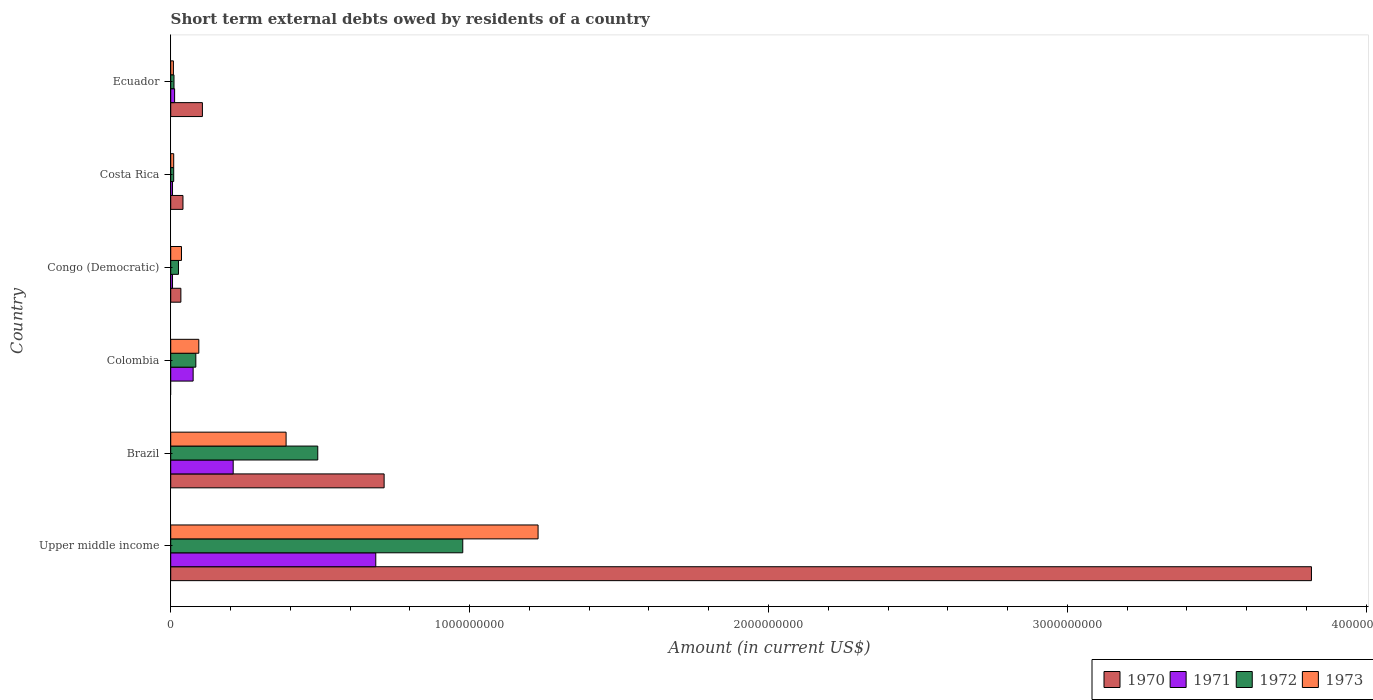How many different coloured bars are there?
Give a very brief answer. 4. How many groups of bars are there?
Ensure brevity in your answer.  6. Are the number of bars per tick equal to the number of legend labels?
Your answer should be compact. No. Are the number of bars on each tick of the Y-axis equal?
Provide a short and direct response. No. How many bars are there on the 4th tick from the top?
Provide a succinct answer. 3. How many bars are there on the 3rd tick from the bottom?
Keep it short and to the point. 3. What is the label of the 6th group of bars from the top?
Your answer should be very brief. Upper middle income. In how many cases, is the number of bars for a given country not equal to the number of legend labels?
Give a very brief answer. 1. What is the amount of short-term external debts owed by residents in 1973 in Upper middle income?
Your response must be concise. 1.23e+09. Across all countries, what is the maximum amount of short-term external debts owed by residents in 1973?
Offer a terse response. 1.23e+09. In which country was the amount of short-term external debts owed by residents in 1971 maximum?
Ensure brevity in your answer.  Upper middle income. What is the total amount of short-term external debts owed by residents in 1971 in the graph?
Provide a succinct answer. 9.95e+08. What is the difference between the amount of short-term external debts owed by residents in 1972 in Colombia and that in Ecuador?
Keep it short and to the point. 7.30e+07. What is the difference between the amount of short-term external debts owed by residents in 1973 in Colombia and the amount of short-term external debts owed by residents in 1972 in Upper middle income?
Ensure brevity in your answer.  -8.83e+08. What is the average amount of short-term external debts owed by residents in 1970 per country?
Make the answer very short. 7.85e+08. What is the difference between the amount of short-term external debts owed by residents in 1972 and amount of short-term external debts owed by residents in 1973 in Colombia?
Provide a succinct answer. -1.00e+07. In how many countries, is the amount of short-term external debts owed by residents in 1970 greater than 800000000 US$?
Make the answer very short. 1. What is the ratio of the amount of short-term external debts owed by residents in 1973 in Brazil to that in Upper middle income?
Provide a succinct answer. 0.31. Is the amount of short-term external debts owed by residents in 1973 in Colombia less than that in Costa Rica?
Provide a succinct answer. No. What is the difference between the highest and the second highest amount of short-term external debts owed by residents in 1972?
Ensure brevity in your answer.  4.85e+08. What is the difference between the highest and the lowest amount of short-term external debts owed by residents in 1971?
Your response must be concise. 6.80e+08. Is the sum of the amount of short-term external debts owed by residents in 1973 in Ecuador and Upper middle income greater than the maximum amount of short-term external debts owed by residents in 1972 across all countries?
Provide a short and direct response. Yes. Are all the bars in the graph horizontal?
Your answer should be compact. Yes. What is the difference between two consecutive major ticks on the X-axis?
Your response must be concise. 1.00e+09. Are the values on the major ticks of X-axis written in scientific E-notation?
Offer a terse response. No. What is the title of the graph?
Keep it short and to the point. Short term external debts owed by residents of a country. What is the label or title of the X-axis?
Your answer should be very brief. Amount (in current US$). What is the Amount (in current US$) in 1970 in Upper middle income?
Your answer should be very brief. 3.82e+09. What is the Amount (in current US$) in 1971 in Upper middle income?
Provide a short and direct response. 6.86e+08. What is the Amount (in current US$) of 1972 in Upper middle income?
Provide a succinct answer. 9.77e+08. What is the Amount (in current US$) in 1973 in Upper middle income?
Provide a succinct answer. 1.23e+09. What is the Amount (in current US$) of 1970 in Brazil?
Make the answer very short. 7.14e+08. What is the Amount (in current US$) in 1971 in Brazil?
Your answer should be very brief. 2.09e+08. What is the Amount (in current US$) in 1972 in Brazil?
Make the answer very short. 4.92e+08. What is the Amount (in current US$) in 1973 in Brazil?
Ensure brevity in your answer.  3.86e+08. What is the Amount (in current US$) in 1971 in Colombia?
Your answer should be very brief. 7.50e+07. What is the Amount (in current US$) in 1972 in Colombia?
Your answer should be very brief. 8.40e+07. What is the Amount (in current US$) of 1973 in Colombia?
Offer a terse response. 9.40e+07. What is the Amount (in current US$) of 1970 in Congo (Democratic)?
Your response must be concise. 3.40e+07. What is the Amount (in current US$) in 1971 in Congo (Democratic)?
Keep it short and to the point. 6.00e+06. What is the Amount (in current US$) in 1972 in Congo (Democratic)?
Make the answer very short. 2.60e+07. What is the Amount (in current US$) of 1973 in Congo (Democratic)?
Your response must be concise. 3.60e+07. What is the Amount (in current US$) in 1970 in Costa Rica?
Ensure brevity in your answer.  4.10e+07. What is the Amount (in current US$) of 1971 in Costa Rica?
Your answer should be compact. 6.00e+06. What is the Amount (in current US$) of 1972 in Costa Rica?
Keep it short and to the point. 1.00e+07. What is the Amount (in current US$) in 1973 in Costa Rica?
Make the answer very short. 1.00e+07. What is the Amount (in current US$) in 1970 in Ecuador?
Keep it short and to the point. 1.06e+08. What is the Amount (in current US$) in 1971 in Ecuador?
Give a very brief answer. 1.30e+07. What is the Amount (in current US$) of 1972 in Ecuador?
Ensure brevity in your answer.  1.10e+07. What is the Amount (in current US$) of 1973 in Ecuador?
Give a very brief answer. 9.00e+06. Across all countries, what is the maximum Amount (in current US$) in 1970?
Offer a terse response. 3.82e+09. Across all countries, what is the maximum Amount (in current US$) in 1971?
Make the answer very short. 6.86e+08. Across all countries, what is the maximum Amount (in current US$) in 1972?
Offer a terse response. 9.77e+08. Across all countries, what is the maximum Amount (in current US$) in 1973?
Your answer should be very brief. 1.23e+09. Across all countries, what is the minimum Amount (in current US$) in 1973?
Offer a terse response. 9.00e+06. What is the total Amount (in current US$) of 1970 in the graph?
Provide a succinct answer. 4.71e+09. What is the total Amount (in current US$) in 1971 in the graph?
Offer a terse response. 9.95e+08. What is the total Amount (in current US$) of 1972 in the graph?
Your response must be concise. 1.60e+09. What is the total Amount (in current US$) of 1973 in the graph?
Ensure brevity in your answer.  1.76e+09. What is the difference between the Amount (in current US$) in 1970 in Upper middle income and that in Brazil?
Give a very brief answer. 3.10e+09. What is the difference between the Amount (in current US$) in 1971 in Upper middle income and that in Brazil?
Provide a succinct answer. 4.77e+08. What is the difference between the Amount (in current US$) of 1972 in Upper middle income and that in Brazil?
Your answer should be compact. 4.85e+08. What is the difference between the Amount (in current US$) in 1973 in Upper middle income and that in Brazil?
Make the answer very short. 8.43e+08. What is the difference between the Amount (in current US$) in 1971 in Upper middle income and that in Colombia?
Offer a terse response. 6.11e+08. What is the difference between the Amount (in current US$) of 1972 in Upper middle income and that in Colombia?
Your response must be concise. 8.93e+08. What is the difference between the Amount (in current US$) in 1973 in Upper middle income and that in Colombia?
Keep it short and to the point. 1.14e+09. What is the difference between the Amount (in current US$) of 1970 in Upper middle income and that in Congo (Democratic)?
Give a very brief answer. 3.78e+09. What is the difference between the Amount (in current US$) of 1971 in Upper middle income and that in Congo (Democratic)?
Provide a short and direct response. 6.80e+08. What is the difference between the Amount (in current US$) of 1972 in Upper middle income and that in Congo (Democratic)?
Ensure brevity in your answer.  9.51e+08. What is the difference between the Amount (in current US$) in 1973 in Upper middle income and that in Congo (Democratic)?
Provide a short and direct response. 1.19e+09. What is the difference between the Amount (in current US$) of 1970 in Upper middle income and that in Costa Rica?
Ensure brevity in your answer.  3.78e+09. What is the difference between the Amount (in current US$) of 1971 in Upper middle income and that in Costa Rica?
Provide a short and direct response. 6.80e+08. What is the difference between the Amount (in current US$) of 1972 in Upper middle income and that in Costa Rica?
Offer a terse response. 9.67e+08. What is the difference between the Amount (in current US$) in 1973 in Upper middle income and that in Costa Rica?
Ensure brevity in your answer.  1.22e+09. What is the difference between the Amount (in current US$) of 1970 in Upper middle income and that in Ecuador?
Keep it short and to the point. 3.71e+09. What is the difference between the Amount (in current US$) in 1971 in Upper middle income and that in Ecuador?
Provide a succinct answer. 6.73e+08. What is the difference between the Amount (in current US$) in 1972 in Upper middle income and that in Ecuador?
Offer a terse response. 9.66e+08. What is the difference between the Amount (in current US$) of 1973 in Upper middle income and that in Ecuador?
Your answer should be compact. 1.22e+09. What is the difference between the Amount (in current US$) of 1971 in Brazil and that in Colombia?
Your answer should be compact. 1.34e+08. What is the difference between the Amount (in current US$) of 1972 in Brazil and that in Colombia?
Offer a very short reply. 4.08e+08. What is the difference between the Amount (in current US$) in 1973 in Brazil and that in Colombia?
Offer a terse response. 2.92e+08. What is the difference between the Amount (in current US$) of 1970 in Brazil and that in Congo (Democratic)?
Provide a succinct answer. 6.80e+08. What is the difference between the Amount (in current US$) in 1971 in Brazil and that in Congo (Democratic)?
Keep it short and to the point. 2.03e+08. What is the difference between the Amount (in current US$) in 1972 in Brazil and that in Congo (Democratic)?
Provide a short and direct response. 4.66e+08. What is the difference between the Amount (in current US$) of 1973 in Brazil and that in Congo (Democratic)?
Make the answer very short. 3.50e+08. What is the difference between the Amount (in current US$) in 1970 in Brazil and that in Costa Rica?
Your answer should be compact. 6.73e+08. What is the difference between the Amount (in current US$) of 1971 in Brazil and that in Costa Rica?
Offer a very short reply. 2.03e+08. What is the difference between the Amount (in current US$) in 1972 in Brazil and that in Costa Rica?
Offer a very short reply. 4.82e+08. What is the difference between the Amount (in current US$) of 1973 in Brazil and that in Costa Rica?
Ensure brevity in your answer.  3.76e+08. What is the difference between the Amount (in current US$) in 1970 in Brazil and that in Ecuador?
Offer a very short reply. 6.08e+08. What is the difference between the Amount (in current US$) in 1971 in Brazil and that in Ecuador?
Provide a succinct answer. 1.96e+08. What is the difference between the Amount (in current US$) in 1972 in Brazil and that in Ecuador?
Keep it short and to the point. 4.81e+08. What is the difference between the Amount (in current US$) of 1973 in Brazil and that in Ecuador?
Offer a very short reply. 3.77e+08. What is the difference between the Amount (in current US$) of 1971 in Colombia and that in Congo (Democratic)?
Offer a very short reply. 6.90e+07. What is the difference between the Amount (in current US$) in 1972 in Colombia and that in Congo (Democratic)?
Your answer should be compact. 5.80e+07. What is the difference between the Amount (in current US$) in 1973 in Colombia and that in Congo (Democratic)?
Offer a very short reply. 5.80e+07. What is the difference between the Amount (in current US$) in 1971 in Colombia and that in Costa Rica?
Offer a very short reply. 6.90e+07. What is the difference between the Amount (in current US$) of 1972 in Colombia and that in Costa Rica?
Offer a very short reply. 7.40e+07. What is the difference between the Amount (in current US$) in 1973 in Colombia and that in Costa Rica?
Offer a terse response. 8.40e+07. What is the difference between the Amount (in current US$) in 1971 in Colombia and that in Ecuador?
Offer a terse response. 6.20e+07. What is the difference between the Amount (in current US$) of 1972 in Colombia and that in Ecuador?
Offer a very short reply. 7.30e+07. What is the difference between the Amount (in current US$) of 1973 in Colombia and that in Ecuador?
Provide a succinct answer. 8.50e+07. What is the difference between the Amount (in current US$) of 1970 in Congo (Democratic) and that in Costa Rica?
Keep it short and to the point. -7.00e+06. What is the difference between the Amount (in current US$) of 1972 in Congo (Democratic) and that in Costa Rica?
Provide a succinct answer. 1.60e+07. What is the difference between the Amount (in current US$) of 1973 in Congo (Democratic) and that in Costa Rica?
Your answer should be very brief. 2.60e+07. What is the difference between the Amount (in current US$) in 1970 in Congo (Democratic) and that in Ecuador?
Your response must be concise. -7.20e+07. What is the difference between the Amount (in current US$) of 1971 in Congo (Democratic) and that in Ecuador?
Keep it short and to the point. -7.00e+06. What is the difference between the Amount (in current US$) of 1972 in Congo (Democratic) and that in Ecuador?
Provide a succinct answer. 1.50e+07. What is the difference between the Amount (in current US$) of 1973 in Congo (Democratic) and that in Ecuador?
Your answer should be very brief. 2.70e+07. What is the difference between the Amount (in current US$) of 1970 in Costa Rica and that in Ecuador?
Give a very brief answer. -6.50e+07. What is the difference between the Amount (in current US$) in 1971 in Costa Rica and that in Ecuador?
Provide a short and direct response. -7.00e+06. What is the difference between the Amount (in current US$) of 1970 in Upper middle income and the Amount (in current US$) of 1971 in Brazil?
Give a very brief answer. 3.61e+09. What is the difference between the Amount (in current US$) in 1970 in Upper middle income and the Amount (in current US$) in 1972 in Brazil?
Offer a very short reply. 3.32e+09. What is the difference between the Amount (in current US$) in 1970 in Upper middle income and the Amount (in current US$) in 1973 in Brazil?
Make the answer very short. 3.43e+09. What is the difference between the Amount (in current US$) in 1971 in Upper middle income and the Amount (in current US$) in 1972 in Brazil?
Your response must be concise. 1.94e+08. What is the difference between the Amount (in current US$) of 1971 in Upper middle income and the Amount (in current US$) of 1973 in Brazil?
Keep it short and to the point. 3.00e+08. What is the difference between the Amount (in current US$) in 1972 in Upper middle income and the Amount (in current US$) in 1973 in Brazil?
Your response must be concise. 5.91e+08. What is the difference between the Amount (in current US$) in 1970 in Upper middle income and the Amount (in current US$) in 1971 in Colombia?
Your answer should be compact. 3.74e+09. What is the difference between the Amount (in current US$) of 1970 in Upper middle income and the Amount (in current US$) of 1972 in Colombia?
Provide a succinct answer. 3.73e+09. What is the difference between the Amount (in current US$) of 1970 in Upper middle income and the Amount (in current US$) of 1973 in Colombia?
Your answer should be very brief. 3.72e+09. What is the difference between the Amount (in current US$) in 1971 in Upper middle income and the Amount (in current US$) in 1972 in Colombia?
Keep it short and to the point. 6.02e+08. What is the difference between the Amount (in current US$) in 1971 in Upper middle income and the Amount (in current US$) in 1973 in Colombia?
Your answer should be very brief. 5.92e+08. What is the difference between the Amount (in current US$) in 1972 in Upper middle income and the Amount (in current US$) in 1973 in Colombia?
Make the answer very short. 8.83e+08. What is the difference between the Amount (in current US$) in 1970 in Upper middle income and the Amount (in current US$) in 1971 in Congo (Democratic)?
Your answer should be very brief. 3.81e+09. What is the difference between the Amount (in current US$) in 1970 in Upper middle income and the Amount (in current US$) in 1972 in Congo (Democratic)?
Ensure brevity in your answer.  3.79e+09. What is the difference between the Amount (in current US$) in 1970 in Upper middle income and the Amount (in current US$) in 1973 in Congo (Democratic)?
Your response must be concise. 3.78e+09. What is the difference between the Amount (in current US$) in 1971 in Upper middle income and the Amount (in current US$) in 1972 in Congo (Democratic)?
Offer a very short reply. 6.60e+08. What is the difference between the Amount (in current US$) in 1971 in Upper middle income and the Amount (in current US$) in 1973 in Congo (Democratic)?
Keep it short and to the point. 6.50e+08. What is the difference between the Amount (in current US$) of 1972 in Upper middle income and the Amount (in current US$) of 1973 in Congo (Democratic)?
Offer a very short reply. 9.41e+08. What is the difference between the Amount (in current US$) in 1970 in Upper middle income and the Amount (in current US$) in 1971 in Costa Rica?
Your answer should be very brief. 3.81e+09. What is the difference between the Amount (in current US$) of 1970 in Upper middle income and the Amount (in current US$) of 1972 in Costa Rica?
Offer a very short reply. 3.81e+09. What is the difference between the Amount (in current US$) in 1970 in Upper middle income and the Amount (in current US$) in 1973 in Costa Rica?
Offer a very short reply. 3.81e+09. What is the difference between the Amount (in current US$) in 1971 in Upper middle income and the Amount (in current US$) in 1972 in Costa Rica?
Your response must be concise. 6.76e+08. What is the difference between the Amount (in current US$) in 1971 in Upper middle income and the Amount (in current US$) in 1973 in Costa Rica?
Give a very brief answer. 6.76e+08. What is the difference between the Amount (in current US$) of 1972 in Upper middle income and the Amount (in current US$) of 1973 in Costa Rica?
Your response must be concise. 9.67e+08. What is the difference between the Amount (in current US$) of 1970 in Upper middle income and the Amount (in current US$) of 1971 in Ecuador?
Offer a very short reply. 3.80e+09. What is the difference between the Amount (in current US$) of 1970 in Upper middle income and the Amount (in current US$) of 1972 in Ecuador?
Offer a very short reply. 3.81e+09. What is the difference between the Amount (in current US$) of 1970 in Upper middle income and the Amount (in current US$) of 1973 in Ecuador?
Your answer should be very brief. 3.81e+09. What is the difference between the Amount (in current US$) in 1971 in Upper middle income and the Amount (in current US$) in 1972 in Ecuador?
Keep it short and to the point. 6.75e+08. What is the difference between the Amount (in current US$) in 1971 in Upper middle income and the Amount (in current US$) in 1973 in Ecuador?
Make the answer very short. 6.77e+08. What is the difference between the Amount (in current US$) in 1972 in Upper middle income and the Amount (in current US$) in 1973 in Ecuador?
Your answer should be very brief. 9.68e+08. What is the difference between the Amount (in current US$) of 1970 in Brazil and the Amount (in current US$) of 1971 in Colombia?
Your response must be concise. 6.39e+08. What is the difference between the Amount (in current US$) in 1970 in Brazil and the Amount (in current US$) in 1972 in Colombia?
Offer a very short reply. 6.30e+08. What is the difference between the Amount (in current US$) in 1970 in Brazil and the Amount (in current US$) in 1973 in Colombia?
Give a very brief answer. 6.20e+08. What is the difference between the Amount (in current US$) of 1971 in Brazil and the Amount (in current US$) of 1972 in Colombia?
Offer a very short reply. 1.25e+08. What is the difference between the Amount (in current US$) in 1971 in Brazil and the Amount (in current US$) in 1973 in Colombia?
Offer a terse response. 1.15e+08. What is the difference between the Amount (in current US$) in 1972 in Brazil and the Amount (in current US$) in 1973 in Colombia?
Provide a short and direct response. 3.98e+08. What is the difference between the Amount (in current US$) in 1970 in Brazil and the Amount (in current US$) in 1971 in Congo (Democratic)?
Offer a terse response. 7.08e+08. What is the difference between the Amount (in current US$) of 1970 in Brazil and the Amount (in current US$) of 1972 in Congo (Democratic)?
Ensure brevity in your answer.  6.88e+08. What is the difference between the Amount (in current US$) in 1970 in Brazil and the Amount (in current US$) in 1973 in Congo (Democratic)?
Your answer should be very brief. 6.78e+08. What is the difference between the Amount (in current US$) of 1971 in Brazil and the Amount (in current US$) of 1972 in Congo (Democratic)?
Keep it short and to the point. 1.83e+08. What is the difference between the Amount (in current US$) in 1971 in Brazil and the Amount (in current US$) in 1973 in Congo (Democratic)?
Make the answer very short. 1.73e+08. What is the difference between the Amount (in current US$) of 1972 in Brazil and the Amount (in current US$) of 1973 in Congo (Democratic)?
Ensure brevity in your answer.  4.56e+08. What is the difference between the Amount (in current US$) in 1970 in Brazil and the Amount (in current US$) in 1971 in Costa Rica?
Provide a short and direct response. 7.08e+08. What is the difference between the Amount (in current US$) in 1970 in Brazil and the Amount (in current US$) in 1972 in Costa Rica?
Make the answer very short. 7.04e+08. What is the difference between the Amount (in current US$) of 1970 in Brazil and the Amount (in current US$) of 1973 in Costa Rica?
Provide a short and direct response. 7.04e+08. What is the difference between the Amount (in current US$) of 1971 in Brazil and the Amount (in current US$) of 1972 in Costa Rica?
Offer a terse response. 1.99e+08. What is the difference between the Amount (in current US$) of 1971 in Brazil and the Amount (in current US$) of 1973 in Costa Rica?
Your answer should be compact. 1.99e+08. What is the difference between the Amount (in current US$) in 1972 in Brazil and the Amount (in current US$) in 1973 in Costa Rica?
Your answer should be compact. 4.82e+08. What is the difference between the Amount (in current US$) of 1970 in Brazil and the Amount (in current US$) of 1971 in Ecuador?
Make the answer very short. 7.01e+08. What is the difference between the Amount (in current US$) in 1970 in Brazil and the Amount (in current US$) in 1972 in Ecuador?
Give a very brief answer. 7.03e+08. What is the difference between the Amount (in current US$) of 1970 in Brazil and the Amount (in current US$) of 1973 in Ecuador?
Make the answer very short. 7.05e+08. What is the difference between the Amount (in current US$) in 1971 in Brazil and the Amount (in current US$) in 1972 in Ecuador?
Your answer should be very brief. 1.98e+08. What is the difference between the Amount (in current US$) in 1971 in Brazil and the Amount (in current US$) in 1973 in Ecuador?
Your answer should be compact. 2.00e+08. What is the difference between the Amount (in current US$) of 1972 in Brazil and the Amount (in current US$) of 1973 in Ecuador?
Your answer should be very brief. 4.83e+08. What is the difference between the Amount (in current US$) in 1971 in Colombia and the Amount (in current US$) in 1972 in Congo (Democratic)?
Your response must be concise. 4.90e+07. What is the difference between the Amount (in current US$) of 1971 in Colombia and the Amount (in current US$) of 1973 in Congo (Democratic)?
Make the answer very short. 3.90e+07. What is the difference between the Amount (in current US$) of 1972 in Colombia and the Amount (in current US$) of 1973 in Congo (Democratic)?
Offer a terse response. 4.80e+07. What is the difference between the Amount (in current US$) of 1971 in Colombia and the Amount (in current US$) of 1972 in Costa Rica?
Give a very brief answer. 6.50e+07. What is the difference between the Amount (in current US$) of 1971 in Colombia and the Amount (in current US$) of 1973 in Costa Rica?
Ensure brevity in your answer.  6.50e+07. What is the difference between the Amount (in current US$) of 1972 in Colombia and the Amount (in current US$) of 1973 in Costa Rica?
Offer a terse response. 7.40e+07. What is the difference between the Amount (in current US$) of 1971 in Colombia and the Amount (in current US$) of 1972 in Ecuador?
Offer a very short reply. 6.40e+07. What is the difference between the Amount (in current US$) of 1971 in Colombia and the Amount (in current US$) of 1973 in Ecuador?
Keep it short and to the point. 6.60e+07. What is the difference between the Amount (in current US$) of 1972 in Colombia and the Amount (in current US$) of 1973 in Ecuador?
Provide a short and direct response. 7.50e+07. What is the difference between the Amount (in current US$) of 1970 in Congo (Democratic) and the Amount (in current US$) of 1971 in Costa Rica?
Give a very brief answer. 2.80e+07. What is the difference between the Amount (in current US$) in 1970 in Congo (Democratic) and the Amount (in current US$) in 1972 in Costa Rica?
Make the answer very short. 2.40e+07. What is the difference between the Amount (in current US$) of 1970 in Congo (Democratic) and the Amount (in current US$) of 1973 in Costa Rica?
Your answer should be compact. 2.40e+07. What is the difference between the Amount (in current US$) of 1971 in Congo (Democratic) and the Amount (in current US$) of 1972 in Costa Rica?
Make the answer very short. -4.00e+06. What is the difference between the Amount (in current US$) of 1972 in Congo (Democratic) and the Amount (in current US$) of 1973 in Costa Rica?
Your answer should be compact. 1.60e+07. What is the difference between the Amount (in current US$) in 1970 in Congo (Democratic) and the Amount (in current US$) in 1971 in Ecuador?
Your answer should be very brief. 2.10e+07. What is the difference between the Amount (in current US$) in 1970 in Congo (Democratic) and the Amount (in current US$) in 1972 in Ecuador?
Your answer should be compact. 2.30e+07. What is the difference between the Amount (in current US$) of 1970 in Congo (Democratic) and the Amount (in current US$) of 1973 in Ecuador?
Offer a very short reply. 2.50e+07. What is the difference between the Amount (in current US$) of 1971 in Congo (Democratic) and the Amount (in current US$) of 1972 in Ecuador?
Ensure brevity in your answer.  -5.00e+06. What is the difference between the Amount (in current US$) in 1972 in Congo (Democratic) and the Amount (in current US$) in 1973 in Ecuador?
Make the answer very short. 1.70e+07. What is the difference between the Amount (in current US$) in 1970 in Costa Rica and the Amount (in current US$) in 1971 in Ecuador?
Provide a short and direct response. 2.80e+07. What is the difference between the Amount (in current US$) in 1970 in Costa Rica and the Amount (in current US$) in 1972 in Ecuador?
Your answer should be very brief. 3.00e+07. What is the difference between the Amount (in current US$) of 1970 in Costa Rica and the Amount (in current US$) of 1973 in Ecuador?
Give a very brief answer. 3.20e+07. What is the difference between the Amount (in current US$) of 1971 in Costa Rica and the Amount (in current US$) of 1972 in Ecuador?
Your answer should be very brief. -5.00e+06. What is the difference between the Amount (in current US$) in 1972 in Costa Rica and the Amount (in current US$) in 1973 in Ecuador?
Offer a very short reply. 1.00e+06. What is the average Amount (in current US$) in 1970 per country?
Keep it short and to the point. 7.85e+08. What is the average Amount (in current US$) in 1971 per country?
Make the answer very short. 1.66e+08. What is the average Amount (in current US$) in 1972 per country?
Your response must be concise. 2.67e+08. What is the average Amount (in current US$) in 1973 per country?
Your response must be concise. 2.94e+08. What is the difference between the Amount (in current US$) in 1970 and Amount (in current US$) in 1971 in Upper middle income?
Provide a succinct answer. 3.13e+09. What is the difference between the Amount (in current US$) in 1970 and Amount (in current US$) in 1972 in Upper middle income?
Give a very brief answer. 2.84e+09. What is the difference between the Amount (in current US$) in 1970 and Amount (in current US$) in 1973 in Upper middle income?
Your answer should be compact. 2.59e+09. What is the difference between the Amount (in current US$) in 1971 and Amount (in current US$) in 1972 in Upper middle income?
Provide a short and direct response. -2.91e+08. What is the difference between the Amount (in current US$) in 1971 and Amount (in current US$) in 1973 in Upper middle income?
Offer a terse response. -5.43e+08. What is the difference between the Amount (in current US$) of 1972 and Amount (in current US$) of 1973 in Upper middle income?
Give a very brief answer. -2.52e+08. What is the difference between the Amount (in current US$) in 1970 and Amount (in current US$) in 1971 in Brazil?
Your response must be concise. 5.05e+08. What is the difference between the Amount (in current US$) in 1970 and Amount (in current US$) in 1972 in Brazil?
Your response must be concise. 2.22e+08. What is the difference between the Amount (in current US$) of 1970 and Amount (in current US$) of 1973 in Brazil?
Provide a short and direct response. 3.28e+08. What is the difference between the Amount (in current US$) in 1971 and Amount (in current US$) in 1972 in Brazil?
Offer a terse response. -2.83e+08. What is the difference between the Amount (in current US$) in 1971 and Amount (in current US$) in 1973 in Brazil?
Your answer should be very brief. -1.77e+08. What is the difference between the Amount (in current US$) in 1972 and Amount (in current US$) in 1973 in Brazil?
Ensure brevity in your answer.  1.06e+08. What is the difference between the Amount (in current US$) in 1971 and Amount (in current US$) in 1972 in Colombia?
Provide a short and direct response. -9.00e+06. What is the difference between the Amount (in current US$) in 1971 and Amount (in current US$) in 1973 in Colombia?
Your answer should be compact. -1.90e+07. What is the difference between the Amount (in current US$) in 1972 and Amount (in current US$) in 1973 in Colombia?
Keep it short and to the point. -1.00e+07. What is the difference between the Amount (in current US$) in 1970 and Amount (in current US$) in 1971 in Congo (Democratic)?
Your answer should be very brief. 2.80e+07. What is the difference between the Amount (in current US$) of 1970 and Amount (in current US$) of 1972 in Congo (Democratic)?
Make the answer very short. 8.00e+06. What is the difference between the Amount (in current US$) of 1971 and Amount (in current US$) of 1972 in Congo (Democratic)?
Make the answer very short. -2.00e+07. What is the difference between the Amount (in current US$) of 1971 and Amount (in current US$) of 1973 in Congo (Democratic)?
Make the answer very short. -3.00e+07. What is the difference between the Amount (in current US$) of 1972 and Amount (in current US$) of 1973 in Congo (Democratic)?
Keep it short and to the point. -1.00e+07. What is the difference between the Amount (in current US$) of 1970 and Amount (in current US$) of 1971 in Costa Rica?
Make the answer very short. 3.50e+07. What is the difference between the Amount (in current US$) of 1970 and Amount (in current US$) of 1972 in Costa Rica?
Provide a succinct answer. 3.10e+07. What is the difference between the Amount (in current US$) in 1970 and Amount (in current US$) in 1973 in Costa Rica?
Offer a very short reply. 3.10e+07. What is the difference between the Amount (in current US$) of 1971 and Amount (in current US$) of 1972 in Costa Rica?
Provide a short and direct response. -4.00e+06. What is the difference between the Amount (in current US$) in 1971 and Amount (in current US$) in 1973 in Costa Rica?
Give a very brief answer. -4.00e+06. What is the difference between the Amount (in current US$) of 1972 and Amount (in current US$) of 1973 in Costa Rica?
Your answer should be compact. 0. What is the difference between the Amount (in current US$) of 1970 and Amount (in current US$) of 1971 in Ecuador?
Offer a very short reply. 9.30e+07. What is the difference between the Amount (in current US$) of 1970 and Amount (in current US$) of 1972 in Ecuador?
Provide a short and direct response. 9.50e+07. What is the difference between the Amount (in current US$) of 1970 and Amount (in current US$) of 1973 in Ecuador?
Offer a very short reply. 9.70e+07. What is the difference between the Amount (in current US$) in 1971 and Amount (in current US$) in 1972 in Ecuador?
Ensure brevity in your answer.  2.00e+06. What is the difference between the Amount (in current US$) in 1971 and Amount (in current US$) in 1973 in Ecuador?
Your answer should be compact. 4.00e+06. What is the ratio of the Amount (in current US$) in 1970 in Upper middle income to that in Brazil?
Your answer should be very brief. 5.35. What is the ratio of the Amount (in current US$) in 1971 in Upper middle income to that in Brazil?
Provide a short and direct response. 3.28. What is the ratio of the Amount (in current US$) of 1972 in Upper middle income to that in Brazil?
Offer a very short reply. 1.99. What is the ratio of the Amount (in current US$) in 1973 in Upper middle income to that in Brazil?
Keep it short and to the point. 3.18. What is the ratio of the Amount (in current US$) in 1971 in Upper middle income to that in Colombia?
Your response must be concise. 9.15. What is the ratio of the Amount (in current US$) in 1972 in Upper middle income to that in Colombia?
Provide a short and direct response. 11.63. What is the ratio of the Amount (in current US$) in 1973 in Upper middle income to that in Colombia?
Ensure brevity in your answer.  13.08. What is the ratio of the Amount (in current US$) of 1970 in Upper middle income to that in Congo (Democratic)?
Your answer should be compact. 112.25. What is the ratio of the Amount (in current US$) of 1971 in Upper middle income to that in Congo (Democratic)?
Provide a short and direct response. 114.35. What is the ratio of the Amount (in current US$) of 1972 in Upper middle income to that in Congo (Democratic)?
Keep it short and to the point. 37.58. What is the ratio of the Amount (in current US$) of 1973 in Upper middle income to that in Congo (Democratic)?
Provide a short and direct response. 34.14. What is the ratio of the Amount (in current US$) in 1970 in Upper middle income to that in Costa Rica?
Provide a succinct answer. 93.09. What is the ratio of the Amount (in current US$) in 1971 in Upper middle income to that in Costa Rica?
Keep it short and to the point. 114.35. What is the ratio of the Amount (in current US$) of 1972 in Upper middle income to that in Costa Rica?
Give a very brief answer. 97.71. What is the ratio of the Amount (in current US$) in 1973 in Upper middle income to that in Costa Rica?
Your answer should be very brief. 122.91. What is the ratio of the Amount (in current US$) of 1970 in Upper middle income to that in Ecuador?
Make the answer very short. 36.01. What is the ratio of the Amount (in current US$) of 1971 in Upper middle income to that in Ecuador?
Your response must be concise. 52.78. What is the ratio of the Amount (in current US$) of 1972 in Upper middle income to that in Ecuador?
Keep it short and to the point. 88.83. What is the ratio of the Amount (in current US$) of 1973 in Upper middle income to that in Ecuador?
Keep it short and to the point. 136.57. What is the ratio of the Amount (in current US$) of 1971 in Brazil to that in Colombia?
Provide a short and direct response. 2.79. What is the ratio of the Amount (in current US$) in 1972 in Brazil to that in Colombia?
Give a very brief answer. 5.86. What is the ratio of the Amount (in current US$) of 1973 in Brazil to that in Colombia?
Provide a succinct answer. 4.11. What is the ratio of the Amount (in current US$) in 1970 in Brazil to that in Congo (Democratic)?
Your answer should be compact. 21. What is the ratio of the Amount (in current US$) of 1971 in Brazil to that in Congo (Democratic)?
Provide a succinct answer. 34.83. What is the ratio of the Amount (in current US$) of 1972 in Brazil to that in Congo (Democratic)?
Your answer should be compact. 18.92. What is the ratio of the Amount (in current US$) in 1973 in Brazil to that in Congo (Democratic)?
Your answer should be very brief. 10.72. What is the ratio of the Amount (in current US$) in 1970 in Brazil to that in Costa Rica?
Provide a short and direct response. 17.41. What is the ratio of the Amount (in current US$) of 1971 in Brazil to that in Costa Rica?
Give a very brief answer. 34.83. What is the ratio of the Amount (in current US$) in 1972 in Brazil to that in Costa Rica?
Your response must be concise. 49.2. What is the ratio of the Amount (in current US$) in 1973 in Brazil to that in Costa Rica?
Your answer should be compact. 38.6. What is the ratio of the Amount (in current US$) in 1970 in Brazil to that in Ecuador?
Your answer should be very brief. 6.74. What is the ratio of the Amount (in current US$) in 1971 in Brazil to that in Ecuador?
Offer a terse response. 16.08. What is the ratio of the Amount (in current US$) in 1972 in Brazil to that in Ecuador?
Make the answer very short. 44.73. What is the ratio of the Amount (in current US$) of 1973 in Brazil to that in Ecuador?
Give a very brief answer. 42.89. What is the ratio of the Amount (in current US$) of 1972 in Colombia to that in Congo (Democratic)?
Your answer should be very brief. 3.23. What is the ratio of the Amount (in current US$) in 1973 in Colombia to that in Congo (Democratic)?
Offer a very short reply. 2.61. What is the ratio of the Amount (in current US$) in 1972 in Colombia to that in Costa Rica?
Keep it short and to the point. 8.4. What is the ratio of the Amount (in current US$) in 1971 in Colombia to that in Ecuador?
Provide a succinct answer. 5.77. What is the ratio of the Amount (in current US$) in 1972 in Colombia to that in Ecuador?
Offer a terse response. 7.64. What is the ratio of the Amount (in current US$) of 1973 in Colombia to that in Ecuador?
Provide a short and direct response. 10.44. What is the ratio of the Amount (in current US$) in 1970 in Congo (Democratic) to that in Costa Rica?
Provide a short and direct response. 0.83. What is the ratio of the Amount (in current US$) in 1971 in Congo (Democratic) to that in Costa Rica?
Offer a terse response. 1. What is the ratio of the Amount (in current US$) in 1972 in Congo (Democratic) to that in Costa Rica?
Offer a very short reply. 2.6. What is the ratio of the Amount (in current US$) in 1973 in Congo (Democratic) to that in Costa Rica?
Your response must be concise. 3.6. What is the ratio of the Amount (in current US$) in 1970 in Congo (Democratic) to that in Ecuador?
Your answer should be compact. 0.32. What is the ratio of the Amount (in current US$) of 1971 in Congo (Democratic) to that in Ecuador?
Provide a short and direct response. 0.46. What is the ratio of the Amount (in current US$) in 1972 in Congo (Democratic) to that in Ecuador?
Your response must be concise. 2.36. What is the ratio of the Amount (in current US$) of 1970 in Costa Rica to that in Ecuador?
Offer a terse response. 0.39. What is the ratio of the Amount (in current US$) of 1971 in Costa Rica to that in Ecuador?
Offer a very short reply. 0.46. What is the ratio of the Amount (in current US$) in 1973 in Costa Rica to that in Ecuador?
Provide a succinct answer. 1.11. What is the difference between the highest and the second highest Amount (in current US$) in 1970?
Keep it short and to the point. 3.10e+09. What is the difference between the highest and the second highest Amount (in current US$) of 1971?
Your answer should be very brief. 4.77e+08. What is the difference between the highest and the second highest Amount (in current US$) in 1972?
Provide a succinct answer. 4.85e+08. What is the difference between the highest and the second highest Amount (in current US$) in 1973?
Your response must be concise. 8.43e+08. What is the difference between the highest and the lowest Amount (in current US$) of 1970?
Offer a terse response. 3.82e+09. What is the difference between the highest and the lowest Amount (in current US$) of 1971?
Offer a terse response. 6.80e+08. What is the difference between the highest and the lowest Amount (in current US$) of 1972?
Keep it short and to the point. 9.67e+08. What is the difference between the highest and the lowest Amount (in current US$) of 1973?
Offer a very short reply. 1.22e+09. 